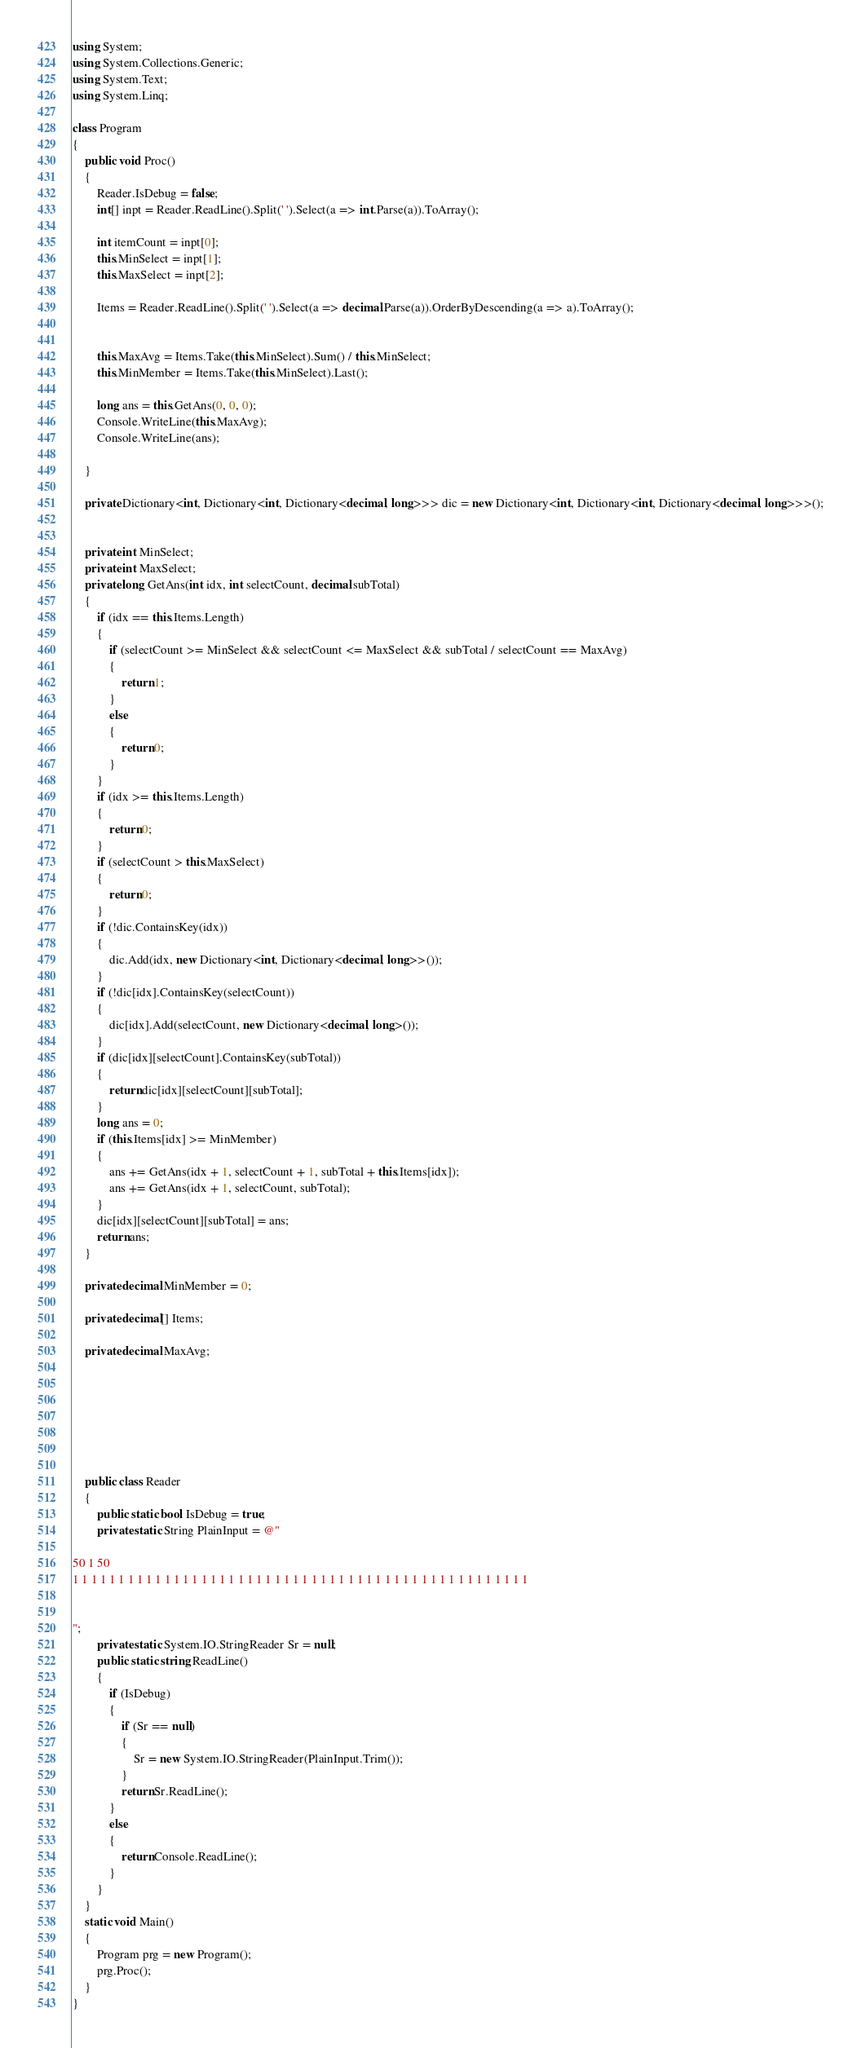Convert code to text. <code><loc_0><loc_0><loc_500><loc_500><_C#_>using System;
using System.Collections.Generic;
using System.Text;
using System.Linq;

class Program
{
    public void Proc()
    {
        Reader.IsDebug = false;
        int[] inpt = Reader.ReadLine().Split(' ').Select(a => int.Parse(a)).ToArray();

        int itemCount = inpt[0];
        this.MinSelect = inpt[1];
        this.MaxSelect = inpt[2];

        Items = Reader.ReadLine().Split(' ').Select(a => decimal.Parse(a)).OrderByDescending(a => a).ToArray();


        this.MaxAvg = Items.Take(this.MinSelect).Sum() / this.MinSelect;
        this.MinMember = Items.Take(this.MinSelect).Last();

        long ans = this.GetAns(0, 0, 0);
        Console.WriteLine(this.MaxAvg);
        Console.WriteLine(ans);

    }

    private Dictionary<int, Dictionary<int, Dictionary<decimal, long>>> dic = new Dictionary<int, Dictionary<int, Dictionary<decimal, long>>>();


    private int MinSelect;
    private int MaxSelect;
    private long GetAns(int idx, int selectCount, decimal subTotal)
    {
        if (idx == this.Items.Length)
        {
            if (selectCount >= MinSelect && selectCount <= MaxSelect && subTotal / selectCount == MaxAvg)
            {
                return 1;
            }
            else
            {
                return 0;
            }
        }
        if (idx >= this.Items.Length)
        {
            return 0;
        }
        if (selectCount > this.MaxSelect)
        {
            return 0;
        }
        if (!dic.ContainsKey(idx))
        {
            dic.Add(idx, new Dictionary<int, Dictionary<decimal, long>>());
        }
        if (!dic[idx].ContainsKey(selectCount))
        {
            dic[idx].Add(selectCount, new Dictionary<decimal, long>());
        }
        if (dic[idx][selectCount].ContainsKey(subTotal))
        {
            return dic[idx][selectCount][subTotal];
        }
        long ans = 0;
        if (this.Items[idx] >= MinMember)
        {
            ans += GetAns(idx + 1, selectCount + 1, subTotal + this.Items[idx]);
            ans += GetAns(idx + 1, selectCount, subTotal);
        }
        dic[idx][selectCount][subTotal] = ans;
        return ans;
    }

    private decimal MinMember = 0;

    private decimal[] Items;

    private decimal MaxAvg;







    public class Reader
    {
        public static bool IsDebug = true;
        private static String PlainInput = @"

50 1 50
1 1 1 1 1 1 1 1 1 1 1 1 1 1 1 1 1 1 1 1 1 1 1 1 1 1 1 1 1 1 1 1 1 1 1 1 1 1 1 1 1 1 1 1 1 1 1 1 1 1


";
        private static System.IO.StringReader Sr = null;
        public static string ReadLine()
        {
            if (IsDebug)
            {
                if (Sr == null)
                {
                    Sr = new System.IO.StringReader(PlainInput.Trim());
                }
                return Sr.ReadLine();
            }
            else
            {
                return Console.ReadLine();
            }
        }
    }
    static void Main()
    {
        Program prg = new Program();
        prg.Proc();
    }
}</code> 